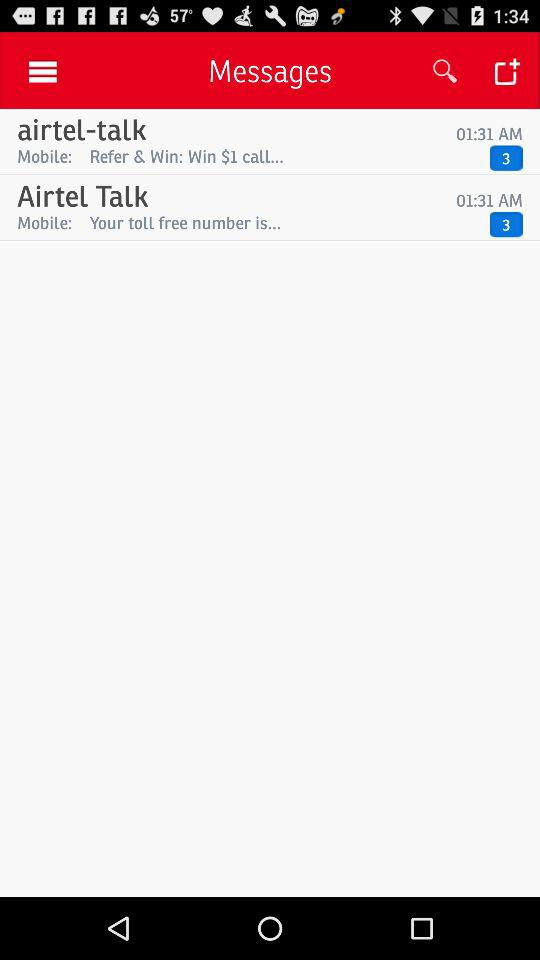How many unread messages are in "airtel-talk"? There are 3 unread messages in "airtel-talk". 